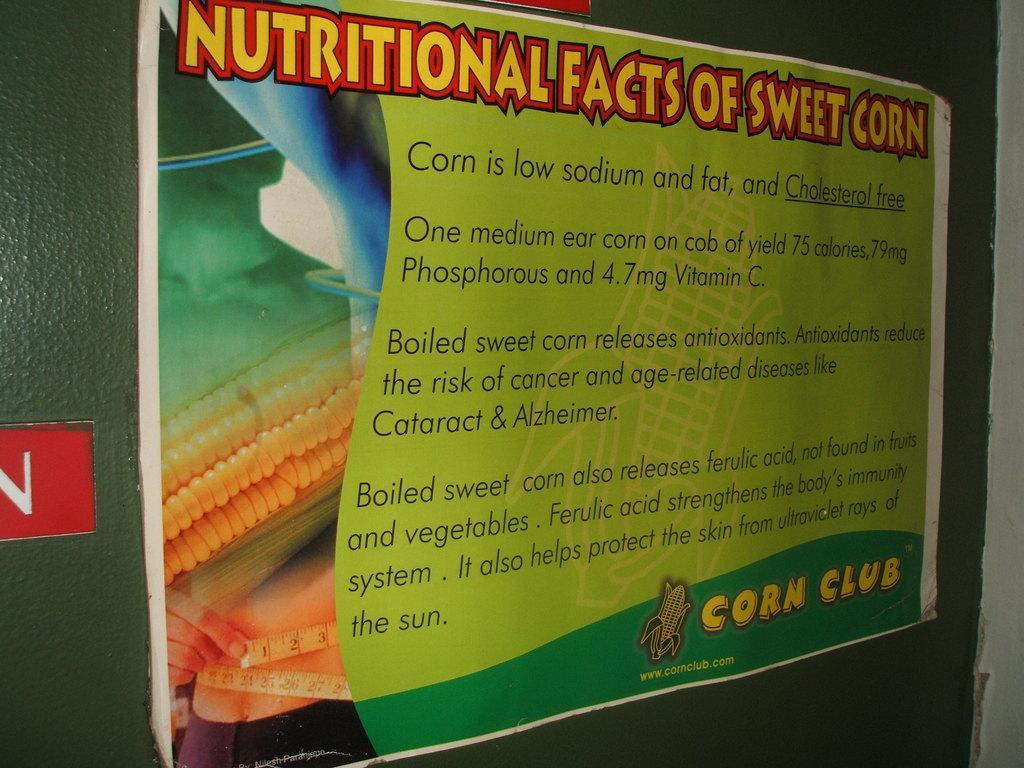In one or two sentences, can you explain what this image depicts? In this picture there is a poster on the wall. On the poster there is a picture of a person and sweet corn and there is text. On the left side of the image there is a board. At the top there is a board. 